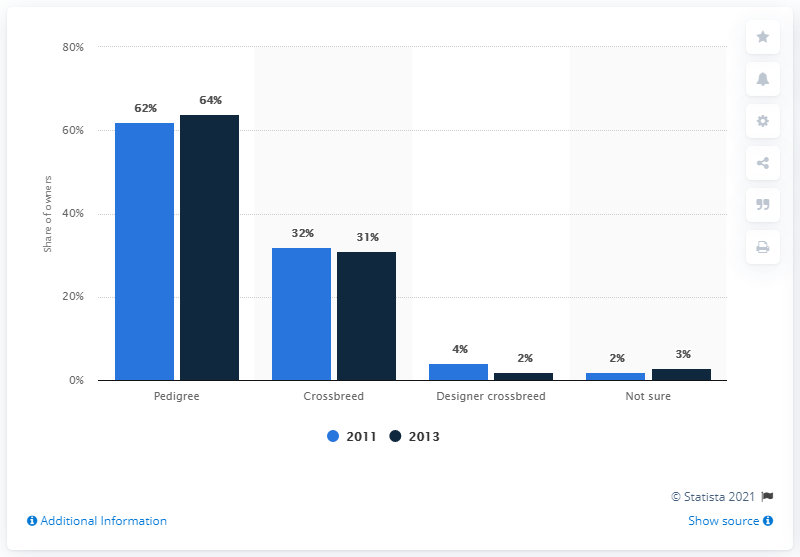Highlight a few significant elements in this photo. In 2013, a significant percentage of dog owners had designer crossbreeds, according to a survey conducted at that time. I'm sorry, but I'm not sure what you are trying to ask. Could you please provide more context or clarify your question? The difference in pedigree types between 2011 and 2013 is two years. 